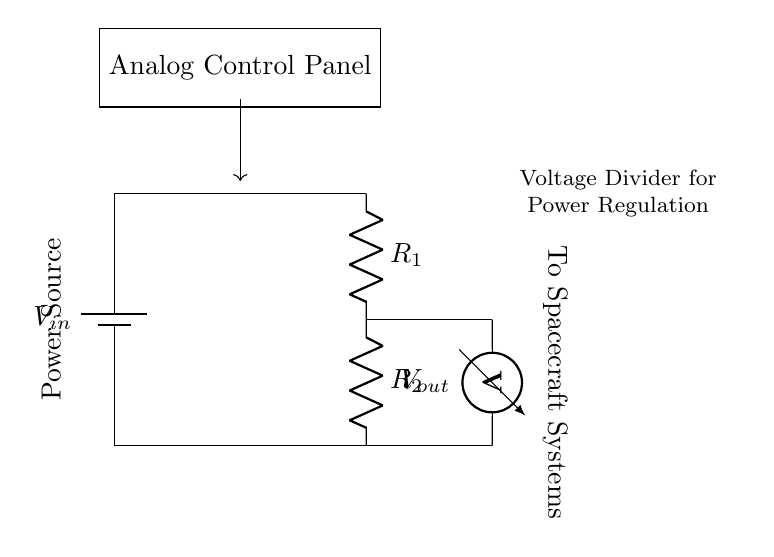What is the input voltage of the circuit? The input voltage is indicated as V_in on the battery in the circuit diagram. By tracing the components, we see that it is represented prominently at the top.
Answer: V_in What are the resistances in this voltage divider? The circuit clearly shows two resistors labeled R_1 and R_2. These components are connected in series in the voltage divider setup.
Answer: R_1 and R_2 Where is the output voltage measured in the circuit? The output voltage, labeled V_out, is measured across the resistor R_2. This is indicated by the voltmeter placement right after R_2 in the schematic.
Answer: Across R_2 What is the role of the battery in this circuit? The battery acts as the power source, providing the input voltage V_in necessary for the operation of the voltage divider, which helps manage power distribution effectively in the control panel.
Answer: Power source How is V_out related to V_in and the resistances? The output voltage V_out can be calculated using the formula V_out = V_in * (R_2 / (R_1 + R_2)). This indicates how voltage is divided based on the percentage of resistances in the circuit.
Answer: V_out = V_in * (R_2 / (R_1 + R_2)) What would happen if R_1 is removed from the circuit? If R_1 is removed, the voltage divider would not function properly because it requires both resistors to divide the input voltage. The output voltage would be equal to the input voltage, affecting the control panel's power regulation.
Answer: Voltage equal to V_in 